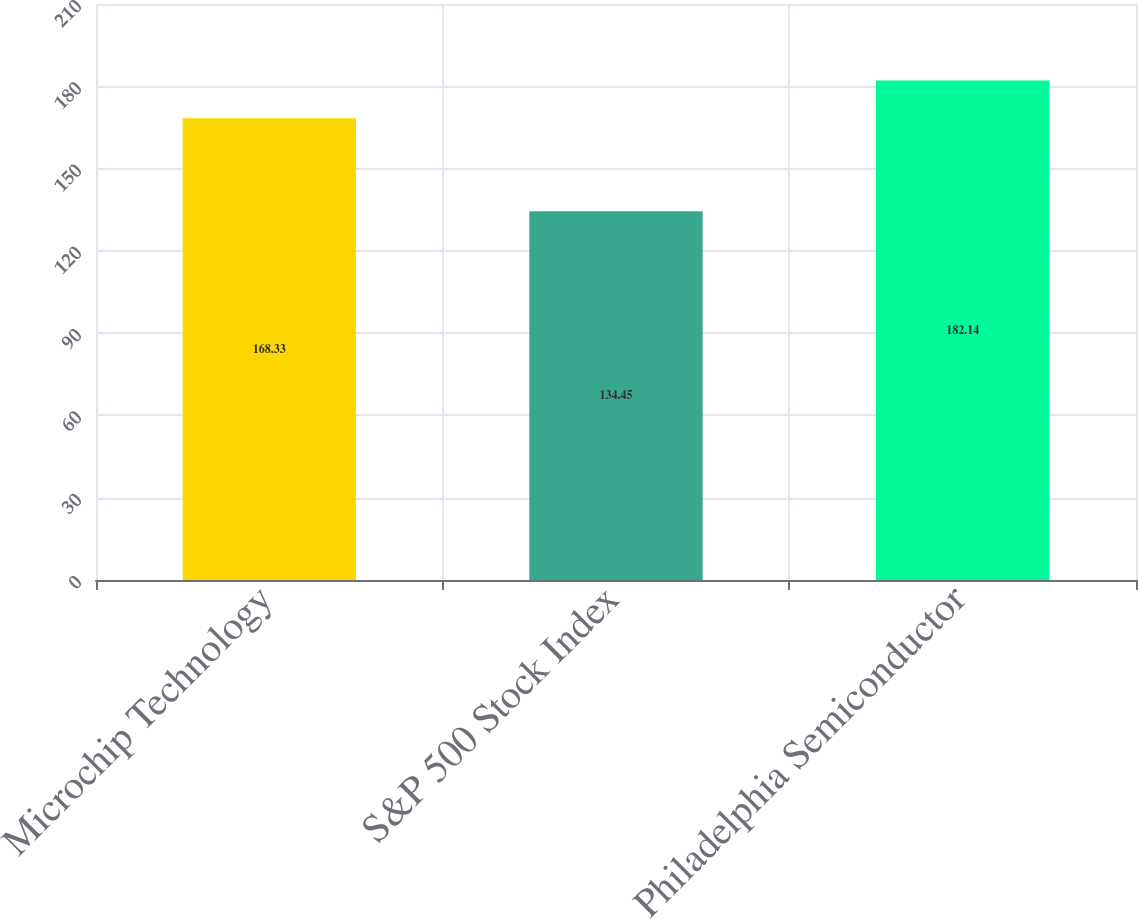Convert chart to OTSL. <chart><loc_0><loc_0><loc_500><loc_500><bar_chart><fcel>Microchip Technology<fcel>S&P 500 Stock Index<fcel>Philadelphia Semiconductor<nl><fcel>168.33<fcel>134.45<fcel>182.14<nl></chart> 